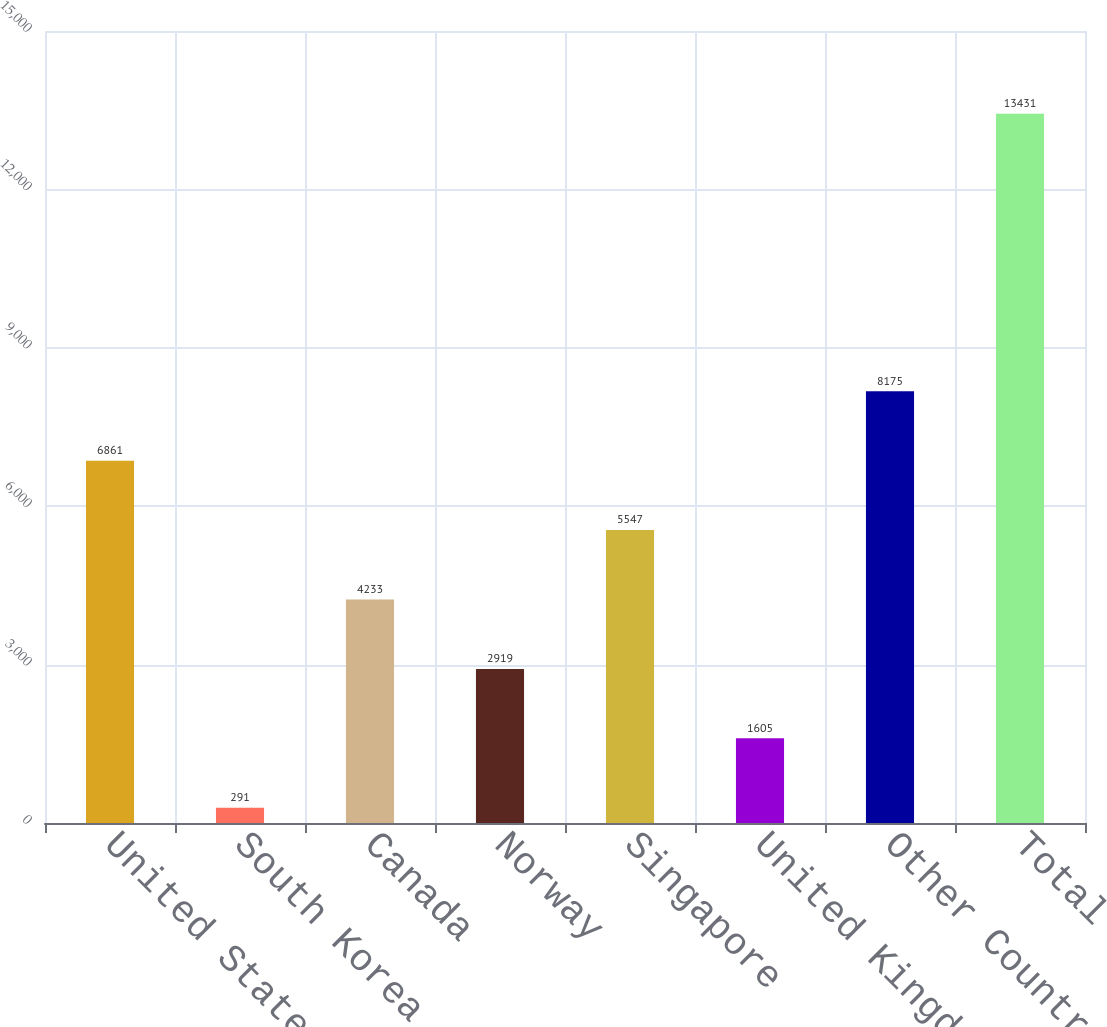Convert chart. <chart><loc_0><loc_0><loc_500><loc_500><bar_chart><fcel>United States<fcel>South Korea<fcel>Canada<fcel>Norway<fcel>Singapore<fcel>United Kingdom<fcel>Other Countries<fcel>Total<nl><fcel>6861<fcel>291<fcel>4233<fcel>2919<fcel>5547<fcel>1605<fcel>8175<fcel>13431<nl></chart> 